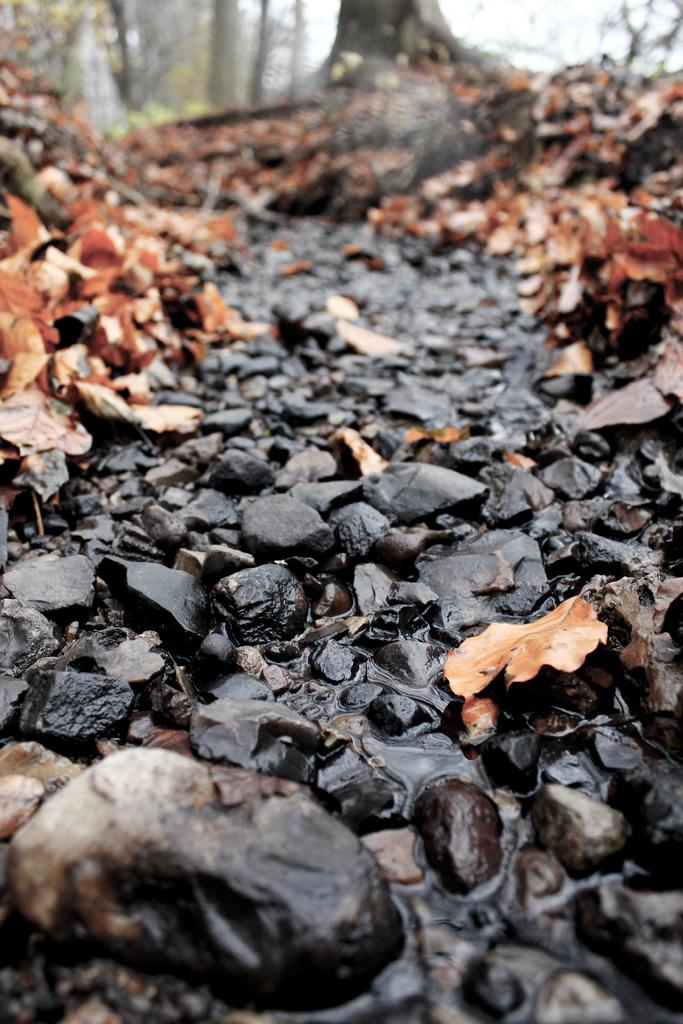What type of path is visible in the image? There is a path with black colored stones in the image. What is happening with the water near the path? Water is flowing from the path. What can be found near the path? Dried leaves are present near the path. What can be seen in the background of the image? There are trees and the sky visible in the background of the image. What type of bun is being used to hold the plot together in the image? There is no plot or bun present in the image; it features a path with black colored stones, water flowing from it, dried leaves, trees, and the sky in the background. 